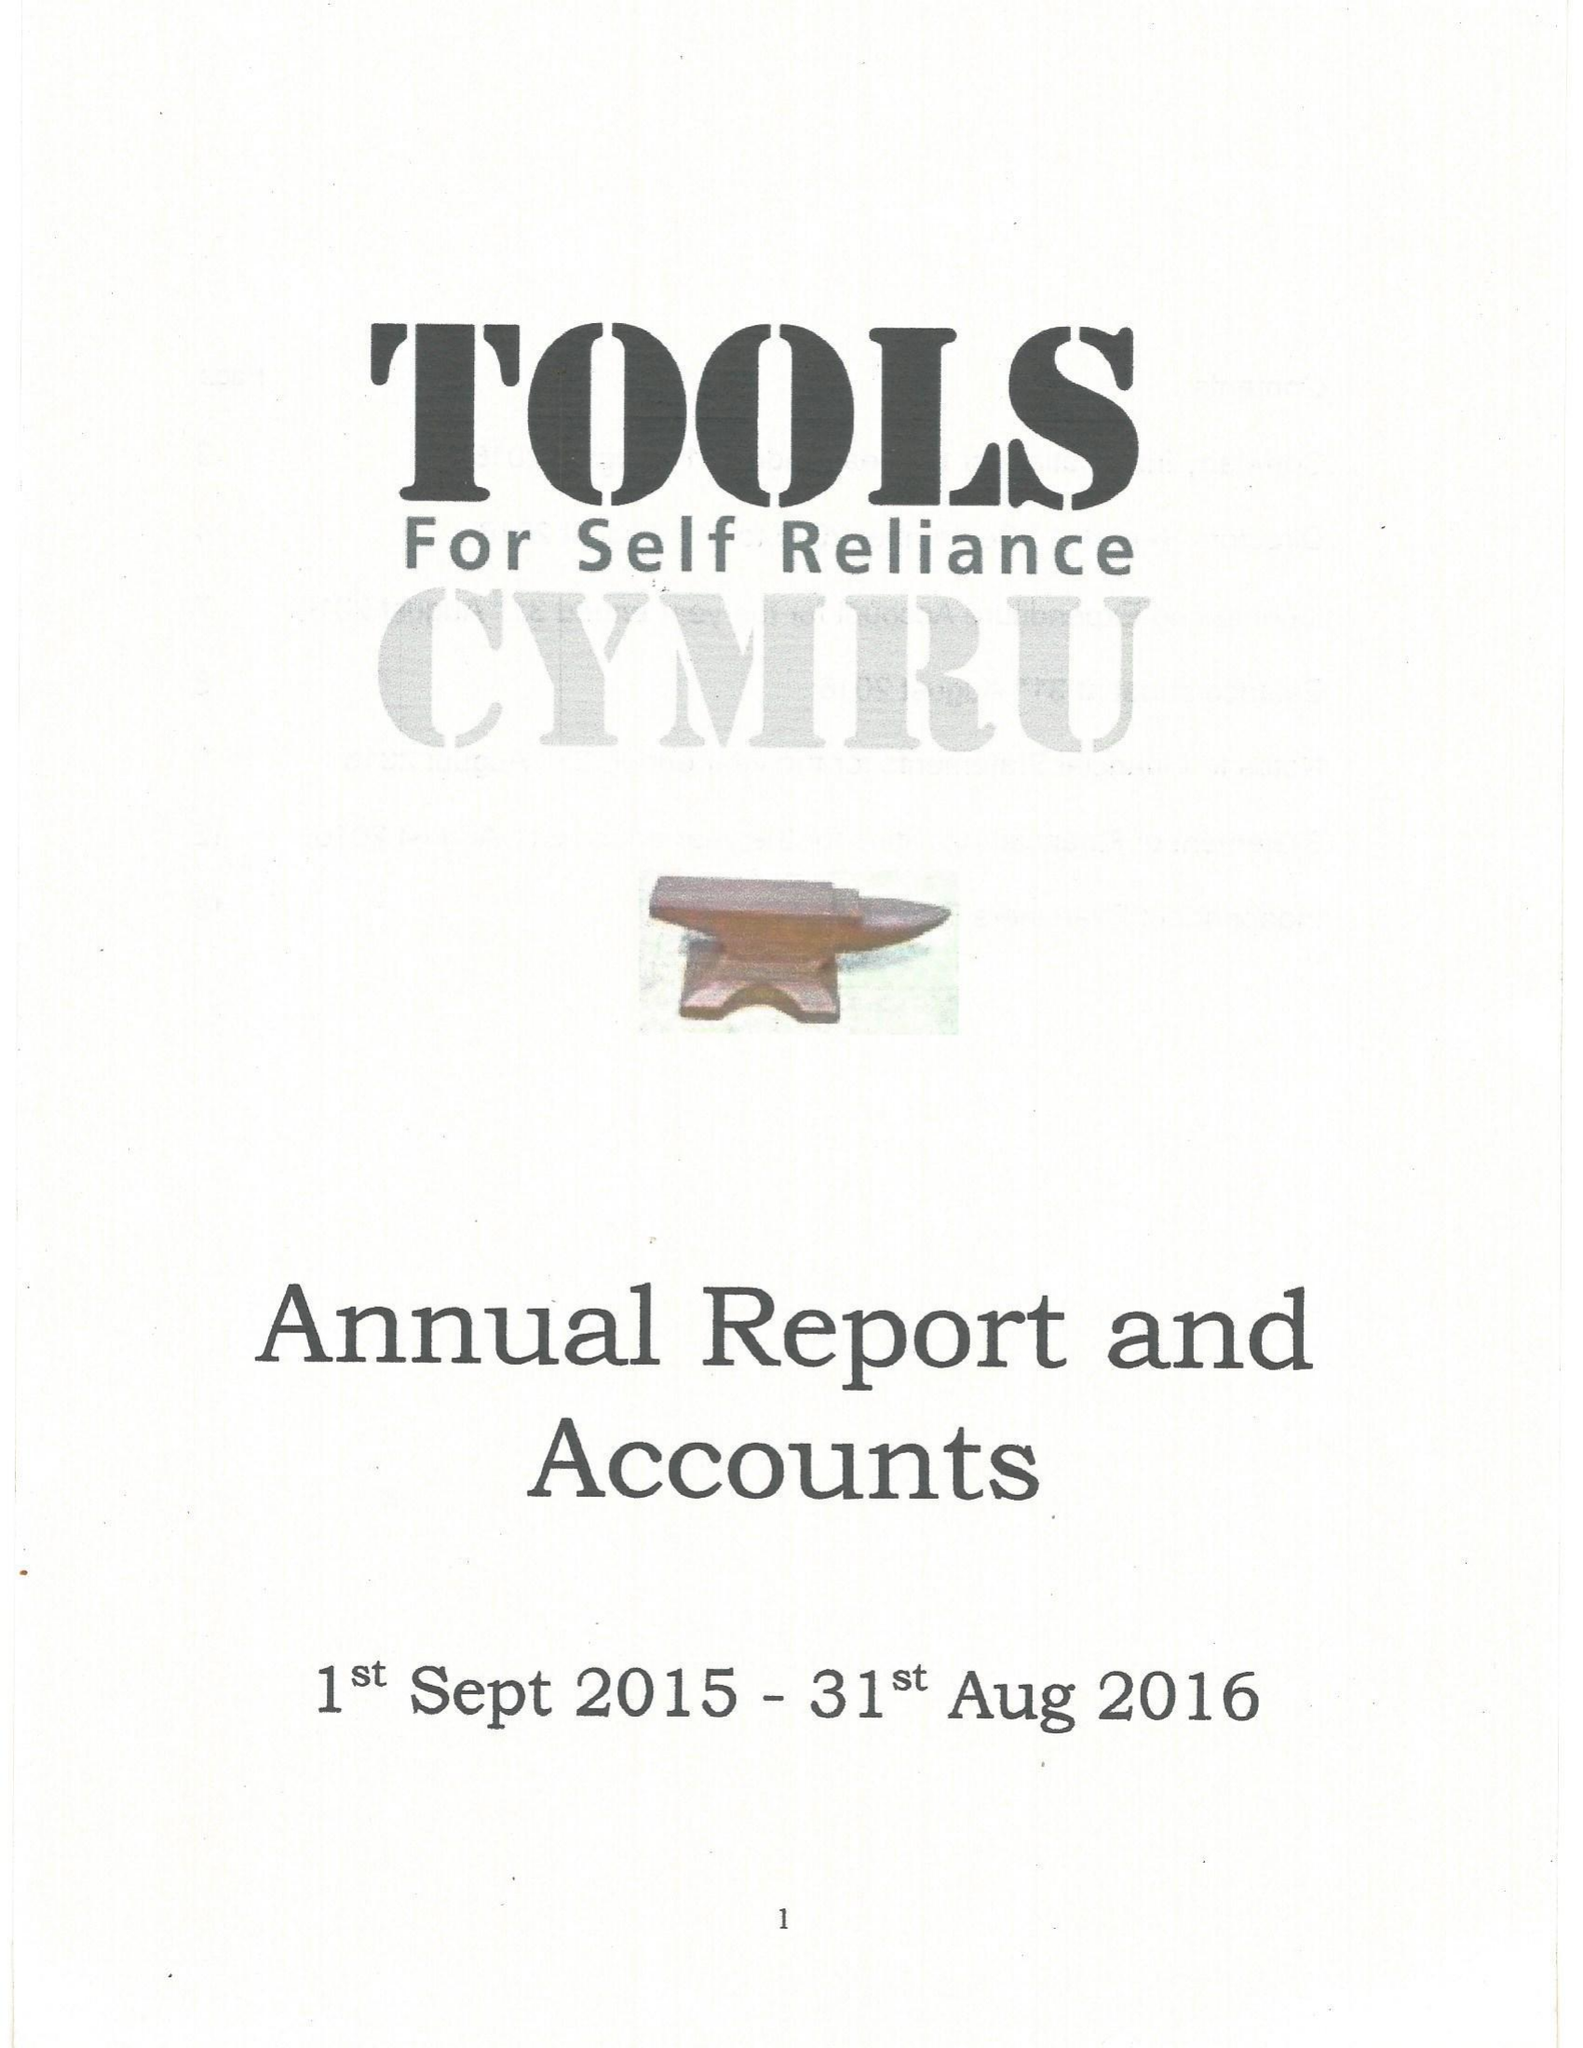What is the value for the address__street_line?
Answer the question using a single word or phrase. None 